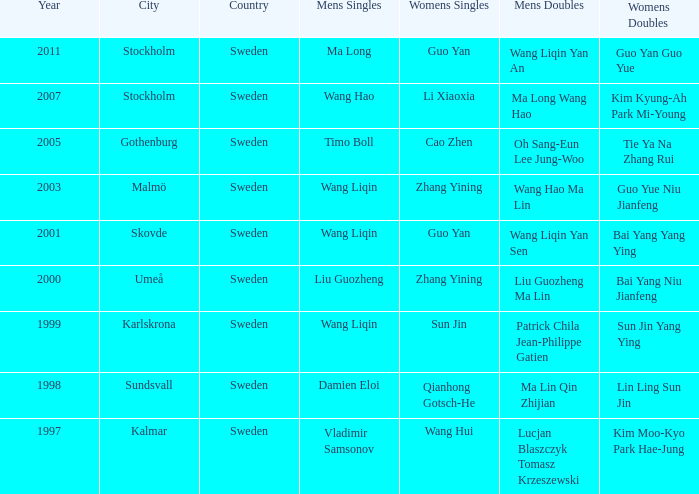How many times has Ma Long won the men's singles? 1.0. 